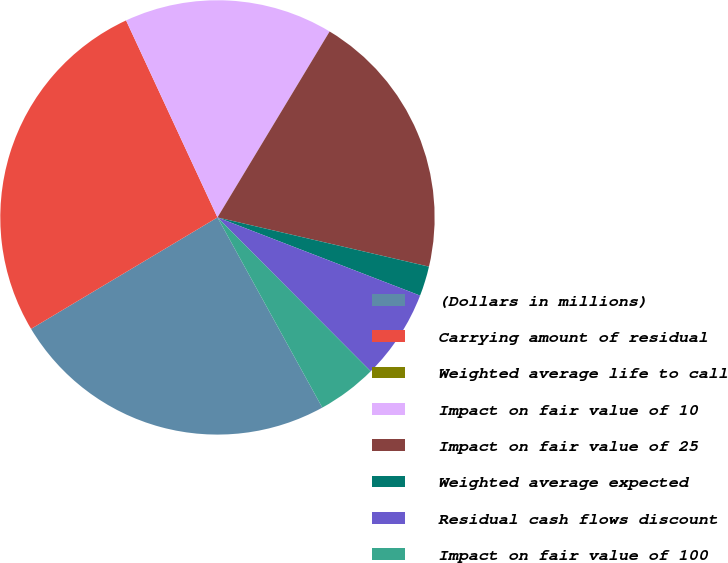Convert chart. <chart><loc_0><loc_0><loc_500><loc_500><pie_chart><fcel>(Dollars in millions)<fcel>Carrying amount of residual<fcel>Weighted average life to call<fcel>Impact on fair value of 10<fcel>Impact on fair value of 25<fcel>Weighted average expected<fcel>Residual cash flows discount<fcel>Impact on fair value of 100<nl><fcel>24.44%<fcel>26.66%<fcel>0.0%<fcel>15.55%<fcel>20.0%<fcel>2.22%<fcel>6.67%<fcel>4.45%<nl></chart> 